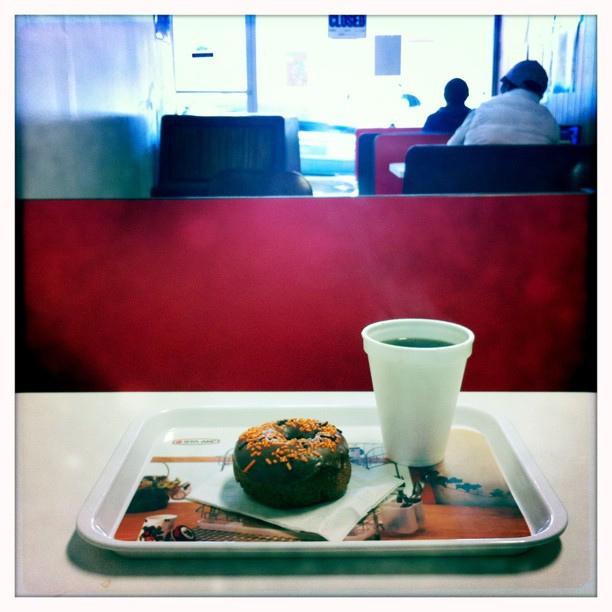What is on the napkin on the tray?
Concise answer only. Donut. Could the beverage be hot?
Keep it brief. Yes. What beverage is in the cup?
Keep it brief. Coffee. 